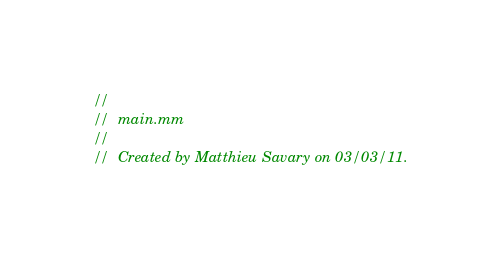Convert code to text. <code><loc_0><loc_0><loc_500><loc_500><_ObjectiveC_>//
//  main.mm
//
//  Created by Matthieu Savary on 03/03/11.</code> 